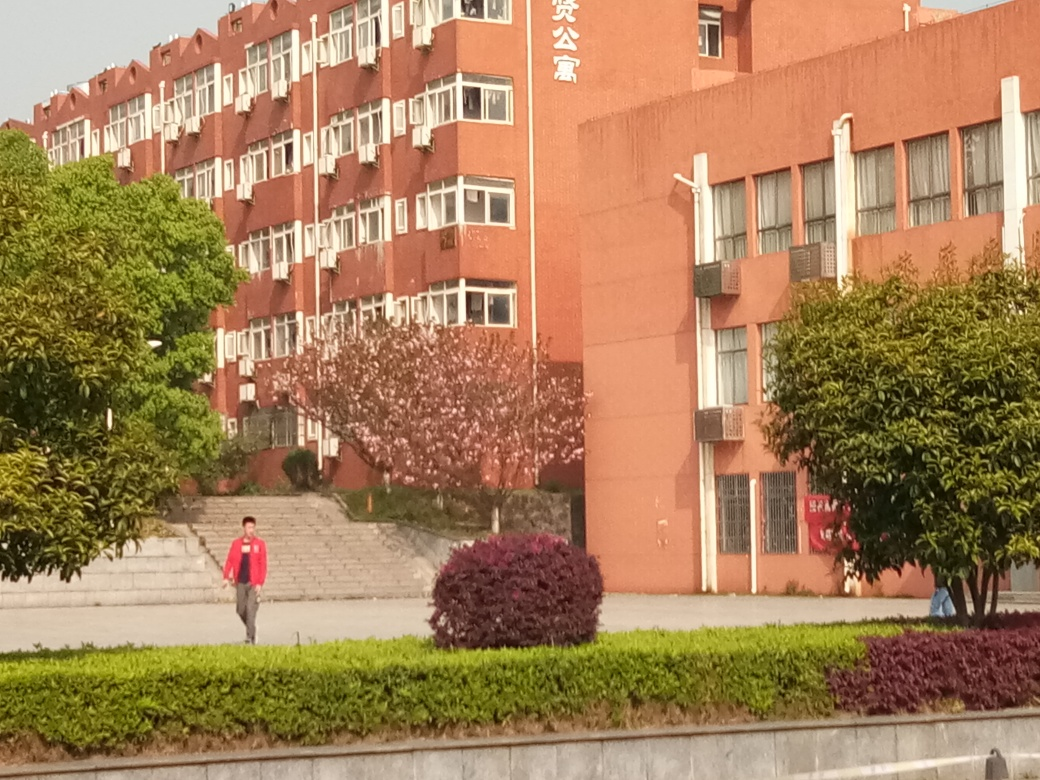Can you describe the architecture and design elements visible in the image? The building architecture in the image is utilitarian, featuring a symmetrical arrangement of windows and balconies that imply a systematic design approach. The reddish-brown color of the building's facade is quite distinctive, complemented by the proportional greenery in the landscape, which introduces organic shapes and textures into the otherwise structured environment. 